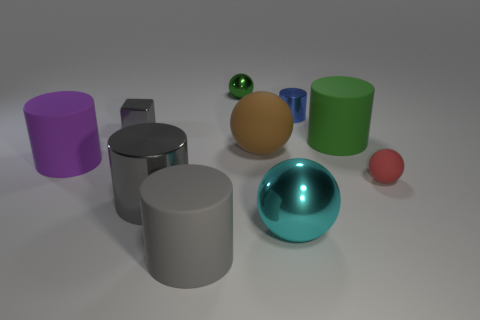Are there an equal number of cyan balls that are behind the gray metal cylinder and big brown spheres?
Keep it short and to the point. No. Is there anything else that has the same material as the big cyan sphere?
Your answer should be very brief. Yes. How many small things are brown spheres or objects?
Provide a short and direct response. 4. What shape is the small object that is the same color as the big metallic cylinder?
Ensure brevity in your answer.  Cube. Are the green object in front of the tiny shiny cube and the small gray cube made of the same material?
Your response must be concise. No. There is a big thing to the left of the tiny shiny thing in front of the small metal cylinder; what is its material?
Your response must be concise. Rubber. How many other objects are the same shape as the green rubber object?
Give a very brief answer. 4. How big is the gray shiny object on the right side of the small object that is to the left of the small sphere on the left side of the large green cylinder?
Your answer should be very brief. Large. What number of gray things are either shiny blocks or shiny cylinders?
Ensure brevity in your answer.  2. There is a green object that is left of the large green matte cylinder; does it have the same shape as the red matte object?
Offer a terse response. Yes. 